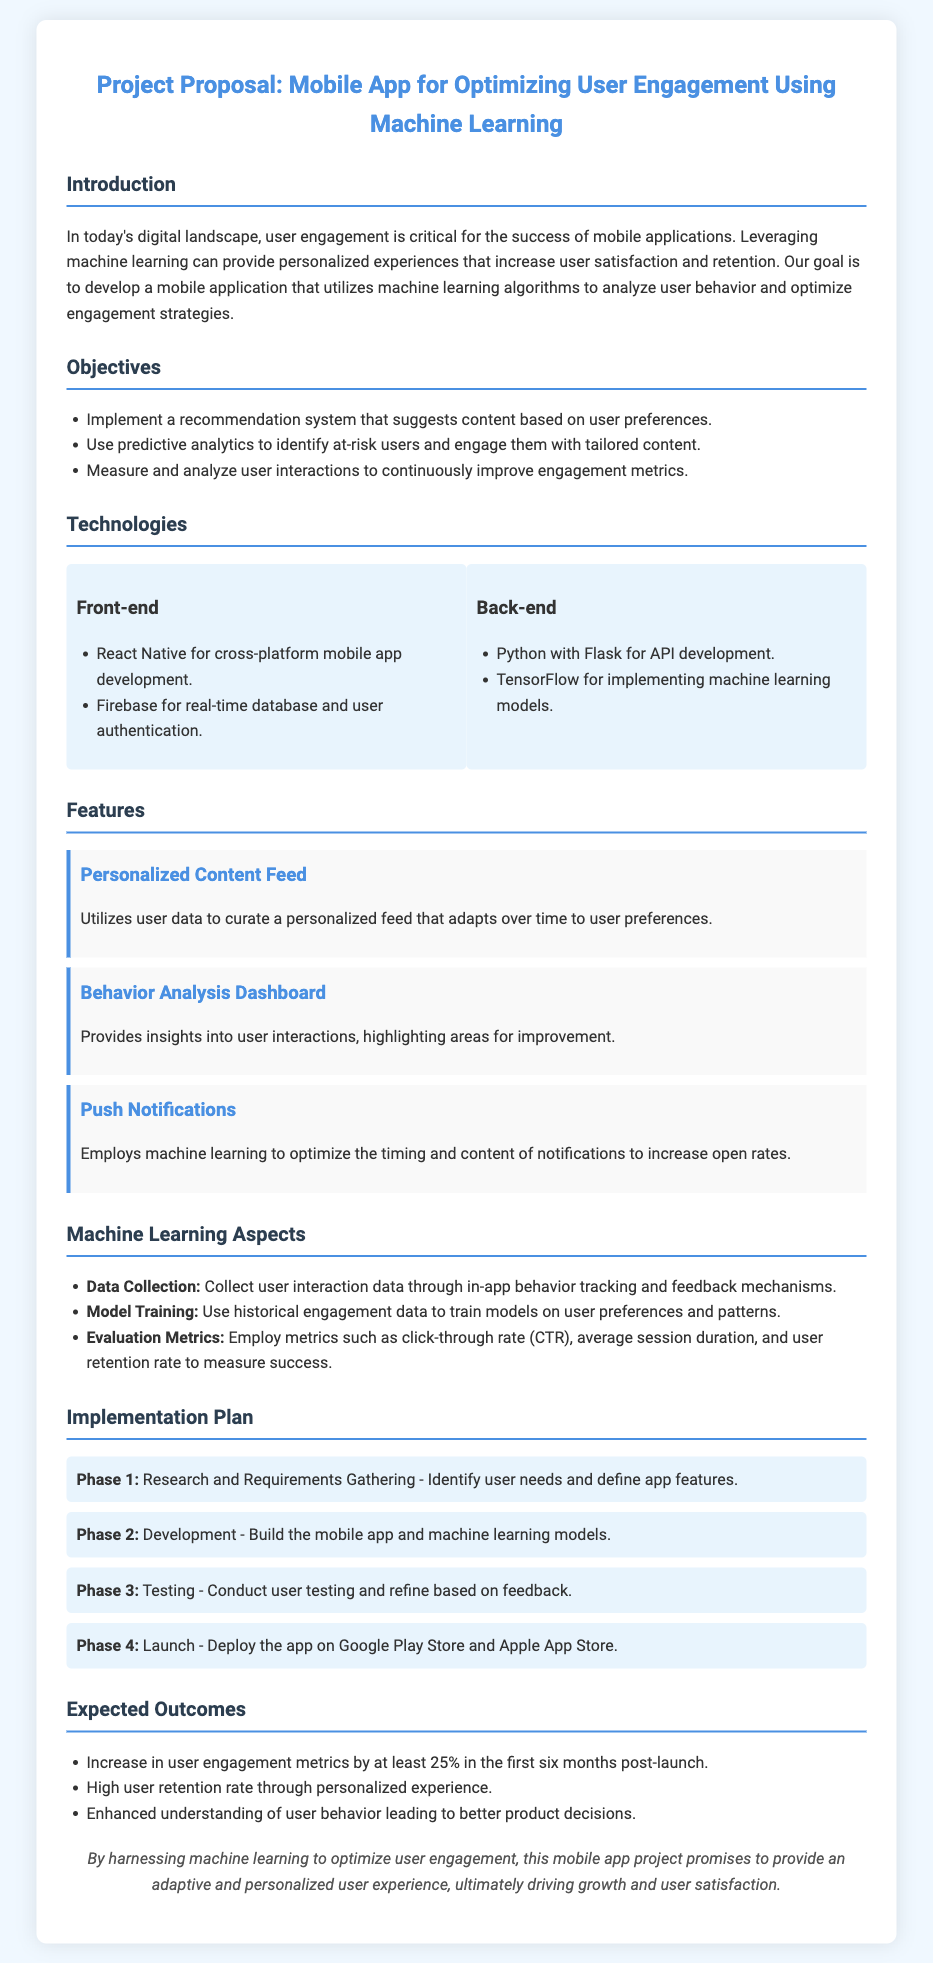What is the main goal of the project? The main goal of the project is to develop a mobile application that utilizes machine learning algorithms to analyze user behavior and optimize engagement strategies.
Answer: Optimize user engagement What technology is used for cross-platform mobile app development? The document specifies that React Native is used for cross-platform mobile app development.
Answer: React Native What is the first phase of the implementation plan? The first phase is Research and Requirements Gathering, which involves identifying user needs and defining app features.
Answer: Research and Requirements Gathering By how much are user engagement metrics expected to increase within the first six months? The expected increase in user engagement metrics is stated to be at least 25% in the first six months post-launch.
Answer: 25% What machine learning framework is mentioned for implementing models? The document mentions TensorFlow as the machine learning framework for implementing models.
Answer: TensorFlow What feature aims to optimize the timing and content of notifications? The feature specifically designed to optimize the timing and content of notifications is Push Notifications.
Answer: Push Notifications What type of analytics will be used to identify at-risk users? Predictive analytics will be utilized to identify at-risk users.
Answer: Predictive analytics Which platform will the app be launched on? The app will be deployed on the Google Play Store and Apple App Store.
Answer: Google Play Store and Apple App Store What is the purpose of the Behavior Analysis Dashboard? The Behavior Analysis Dashboard provides insights into user interactions, highlighting areas for improvement.
Answer: Insights into user interactions 